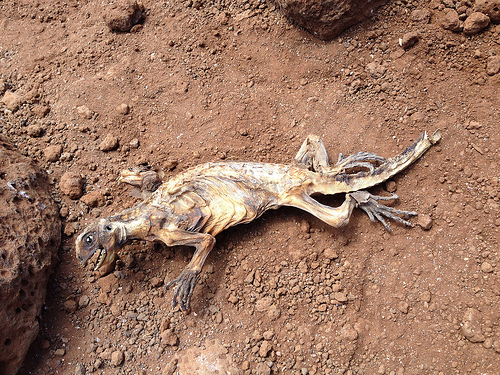<image>
Can you confirm if the rock is in front of the fossil? No. The rock is not in front of the fossil. The spatial positioning shows a different relationship between these objects. 